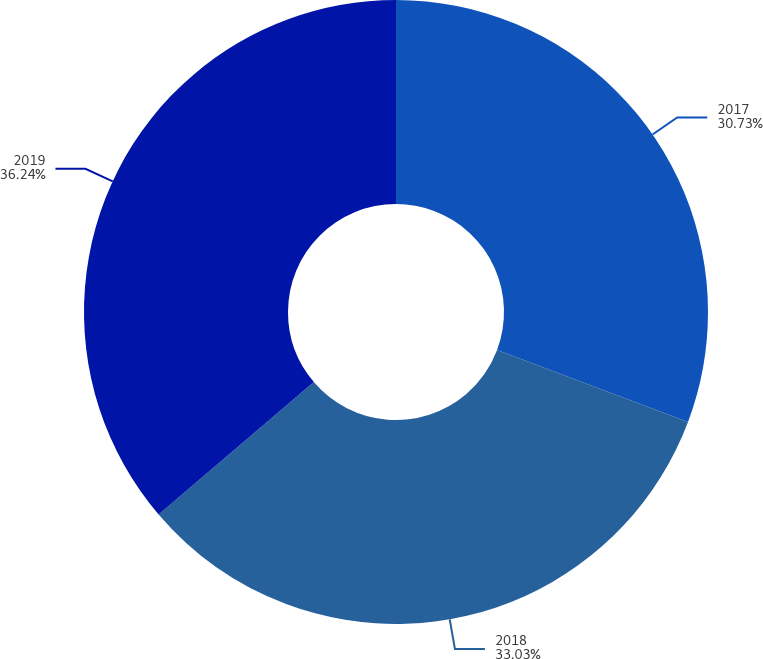Convert chart. <chart><loc_0><loc_0><loc_500><loc_500><pie_chart><fcel>2017<fcel>2018<fcel>2019<nl><fcel>30.73%<fcel>33.03%<fcel>36.24%<nl></chart> 